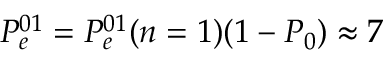<formula> <loc_0><loc_0><loc_500><loc_500>P _ { e } ^ { 0 1 } = P _ { e } ^ { 0 1 } ( n = 1 ) ( 1 - P _ { 0 } ) \approx 7 \</formula> 